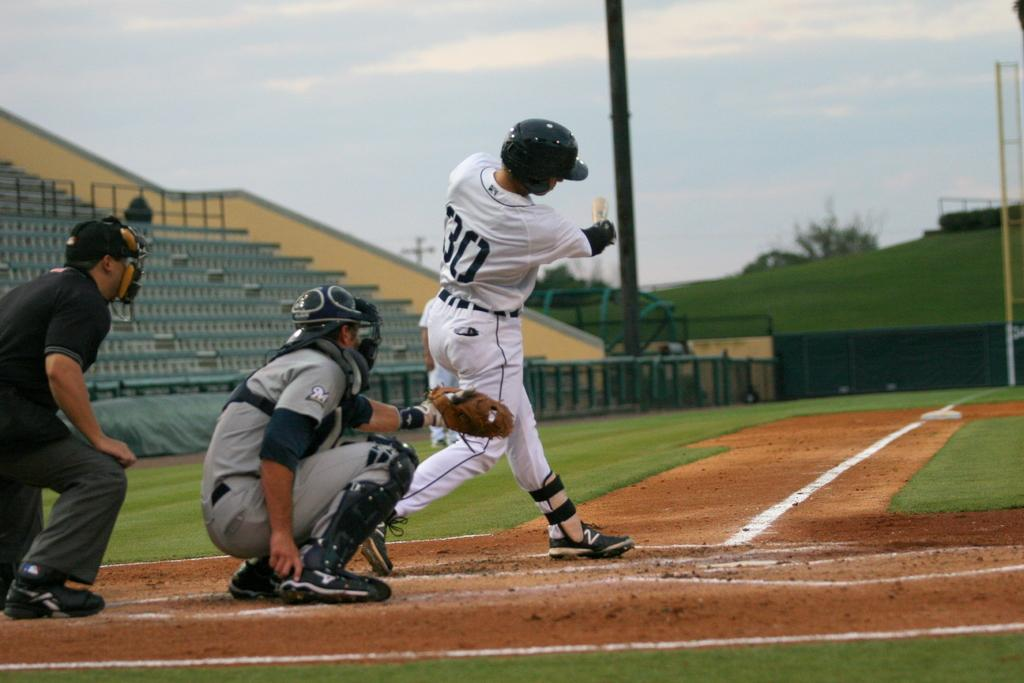<image>
Write a terse but informative summary of the picture. A batter wearing a 30 on his uniform swings at a pitch. 